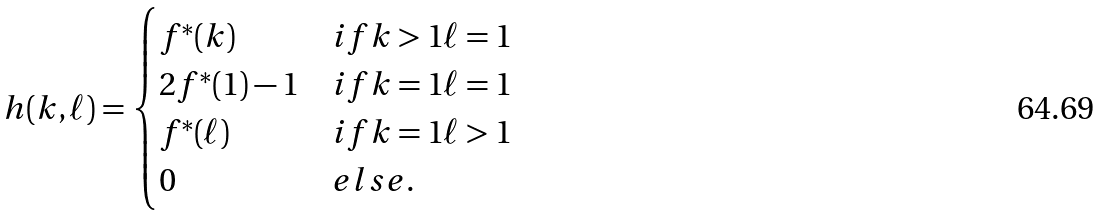<formula> <loc_0><loc_0><loc_500><loc_500>h ( k , \ell ) = \begin{cases} f ^ { \ast } ( k ) & i f k > 1 \ell = 1 \\ 2 f ^ { \ast } ( 1 ) - 1 & i f k = 1 \ell = 1 \\ f ^ { \ast } ( \ell ) & i f k = 1 \ell > 1 \\ 0 & e l s e . \end{cases}</formula> 